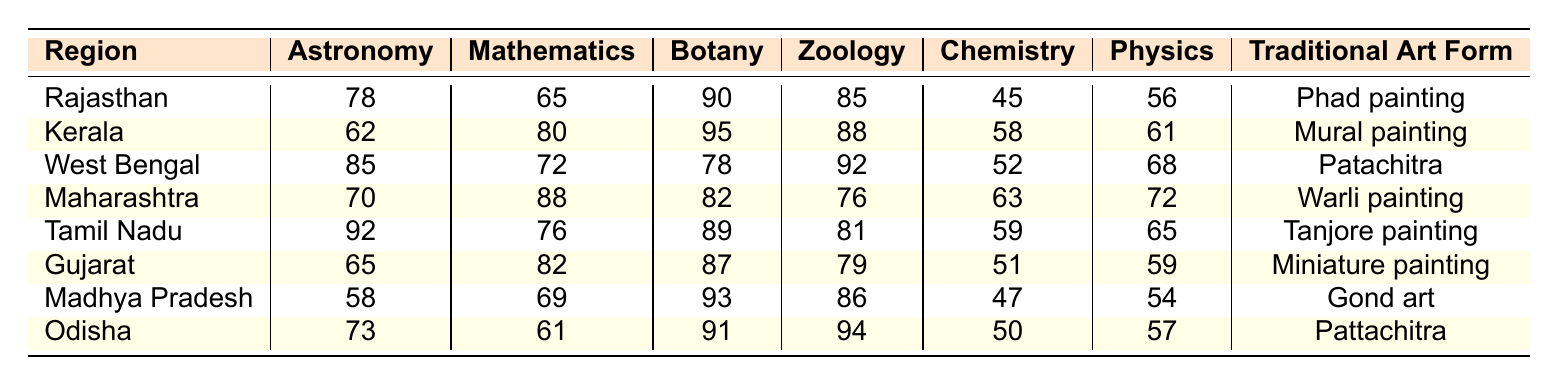What is the scientific theme represented the most in Rajasthan? In the table, the highest frequency value for the region Rajasthan is for Botany, which has a score of 90, higher than other themes listed.
Answer: Botany Which region has the lowest representation of Chemistry? In the table, the lowest value for Chemistry is 45, which corresponds to Rajasthan.
Answer: Rajasthan What is the average score for Zoology across all regions? To calculate the average for Zoology, sum the scores (85 + 88 + 92 + 76 + 81 + 79 + 86 + 94) =  741, and then divide by the number of regions (8), making the average 741/8 = 92.625.
Answer: 92.625 Is there a region where the Astronomy score is exactly 70? Checking the table, Maharashtra has a score of 70 in Astronomy, confirming the statement is true.
Answer: Yes Which traditional art form corresponds to the highest average score in Botany? Looking at the average scores for Botany, Tamil Nadu has a score of 89, which is the highest among the listed regions, corresponding to Tanjore painting.
Answer: Tanjore painting What are the total scores for Physics in Kerala and Karnataka? First, find the scores. Kerala has 61 and Karnataka has no data in the table. Since Karnataka does not exist in the table, we only consider Kerala's score. Thus, the total is just 61.
Answer: 61 Does any region have a score for Mathematics higher than 80? By examining the scores, both Kerala (80) and Maharashtra (88) have scores higher than 80, confirming that there are regions that meet the criterion.
Answer: Yes Which region has the highest score in Astronomy, and what is the score? The table indicates that Tamil Nadu has the highest score in Astronomy, which is 92.
Answer: Tamil Nadu, 92 Calculate the difference between the highest and lowest scores for Chemistry. The highest score in Chemistry is 63 from Maharashtra and the lowest is 45 from Rajasthan. So, the difference is 63 - 45 = 18.
Answer: 18 What is the total representation of all scientific themes for Odisha? Adding up the scores from each theme for Odisha (73 + 61 + 91 + 94 + 50 + 57) gives a total of 426.
Answer: 426 